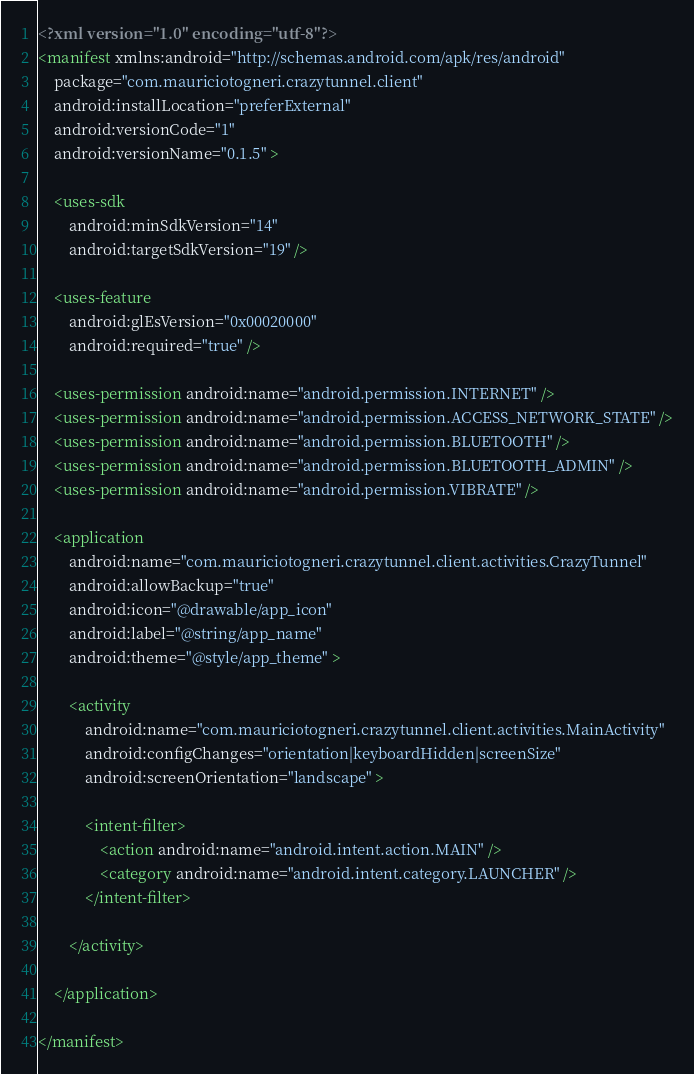<code> <loc_0><loc_0><loc_500><loc_500><_XML_><?xml version="1.0" encoding="utf-8"?>
<manifest xmlns:android="http://schemas.android.com/apk/res/android"
    package="com.mauriciotogneri.crazytunnel.client"
    android:installLocation="preferExternal"
    android:versionCode="1"
    android:versionName="0.1.5" >

    <uses-sdk
        android:minSdkVersion="14"
        android:targetSdkVersion="19" />

    <uses-feature
        android:glEsVersion="0x00020000"
        android:required="true" />
    
    <uses-permission android:name="android.permission.INTERNET" />
    <uses-permission android:name="android.permission.ACCESS_NETWORK_STATE" />
    <uses-permission android:name="android.permission.BLUETOOTH" />
    <uses-permission android:name="android.permission.BLUETOOTH_ADMIN" />
    <uses-permission android:name="android.permission.VIBRATE" />
    
    <application
        android:name="com.mauriciotogneri.crazytunnel.client.activities.CrazyTunnel"
        android:allowBackup="true"
        android:icon="@drawable/app_icon"
        android:label="@string/app_name"
        android:theme="@style/app_theme" >
        
        <activity
            android:name="com.mauriciotogneri.crazytunnel.client.activities.MainActivity"
            android:configChanges="orientation|keyboardHidden|screenSize"
            android:screenOrientation="landscape" >
            
            <intent-filter>
                <action android:name="android.intent.action.MAIN" />
                <category android:name="android.intent.category.LAUNCHER" />
            </intent-filter>
            
        </activity>
        
    </application>

</manifest></code> 